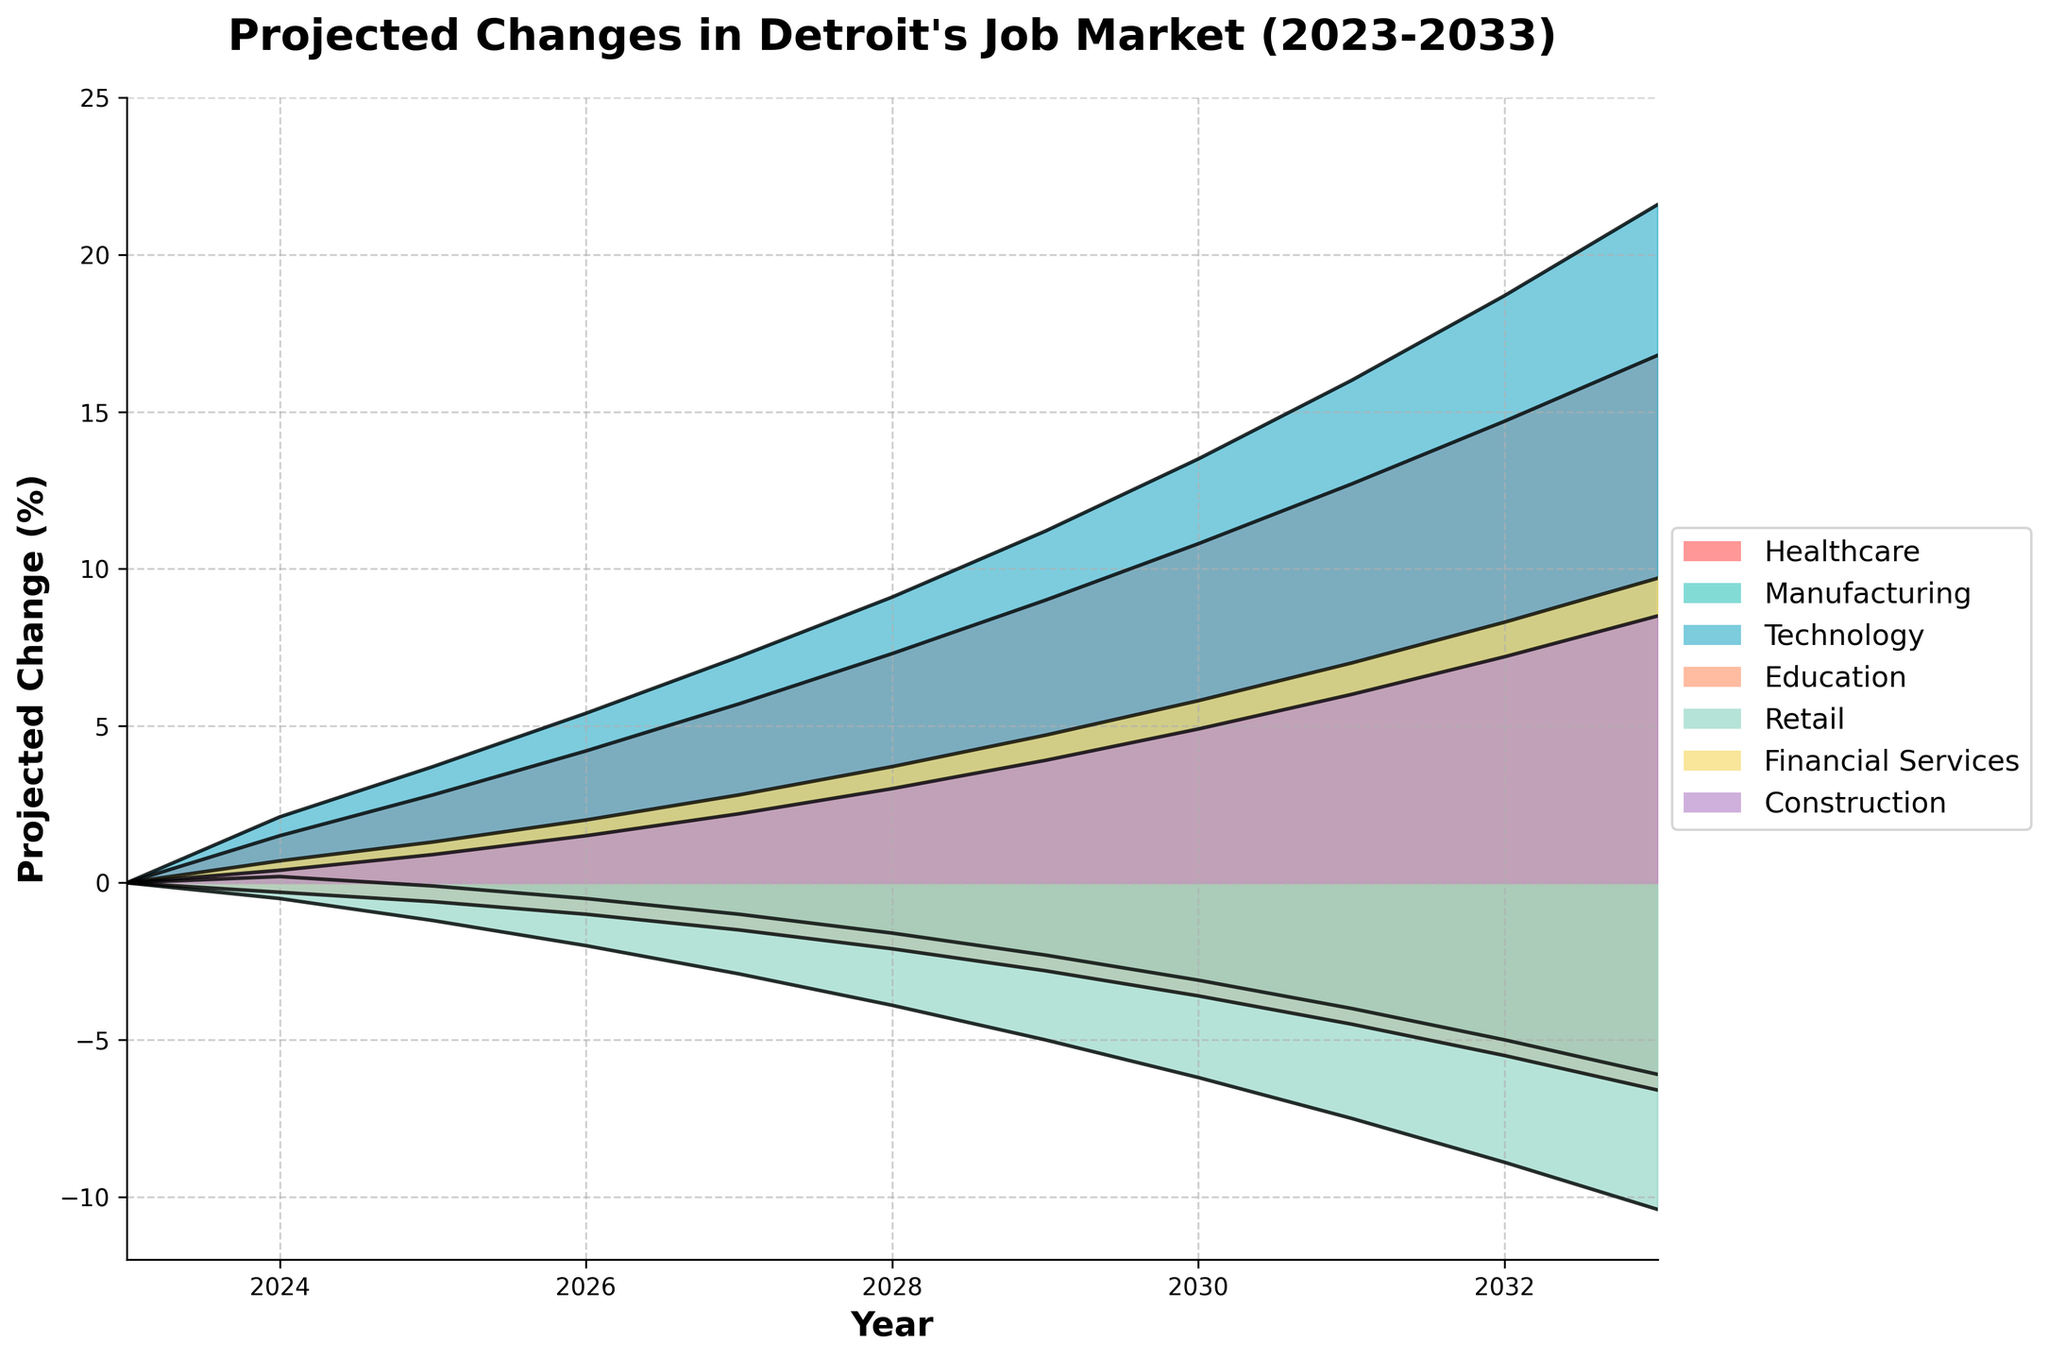What is the title of the figure? The title is a text element displayed prominently at the top of the figure. It summarizes the main focus of the chart. The title of the figure is "Projected Changes in Detroit's Job Market (2023-2033)"
Answer: Projected Changes in Detroit's Job Market (2023-2033) Which industry has the highest projected change in 2033? To determine which industry has the highest projected change in 2033, examine the endpoints of the lines representing each industry on the chart. The line that extends furthest upward at the year 2033 indicates the highest projection. The Technology industry line reaches the highest point.
Answer: Technology Which industry is projected to decline the most over the years? To find out which industry is projected to decline the most, look for the sector line that ends with the most negative value in 2033. The Retail industry line is the lowest in 2033, indicating the most significant decline.
Answer: Retail What is the projected change in the Healthcare industry in 2027? Locate the line or area representing the Healthcare industry on the chart. Follow the line to the year 2027 on the x-axis and read the value on the y-axis at that point. The projected change in the Healthcare industry in 2027 is 5.7%.
Answer: 5.7% Compare the projected changes in the Manufacturing and Financial Services industries in 2030. Which one is higher? To compare, locate the lines for both Manufacturing and Financial Services on the chart. Follow them to the year 2030, and compare the y-axis values. Manufacturing is at -3.1% and Financial Services is at 5.8%. Financial Services has a higher projected change.
Answer: Financial Services What is the overall trend for the Technology industry from 2023 to 2033? Observe the line representing the Technology industry. Note the progression of its values from 2023 to 2033. The line continuously rises, indicating a steadily increasing trend over the decade.
Answer: Increasing trend Calculate the difference in projected changes between the Healthcare and Retail industries in 2031. Identify the projected changes for both Healthcare and Retail in 2031 on the chart. Subtract the Retail value from the Healthcare value: 12.7% (Healthcare) - (-7.5%) (Retail) = 20.2%.
Answer: 20.2% Which industry shows the most fluctuation over the period from 2023 to 2033? To find the most fluctuating industry, observe the amplitude of each line's ups and downs over the years. While most lines rise or fall steadily, the Manufacturing industry's line shows ups and downs before a steady decline, indicating the most fluctuation.
Answer: Manufacturing Does the Construction industry show a positive or negative trend overall? Follow the Construction industry's line from 2023 to 2033. The line consistently rises over the decade, indicating an overall positive trend.
Answer: Positive 